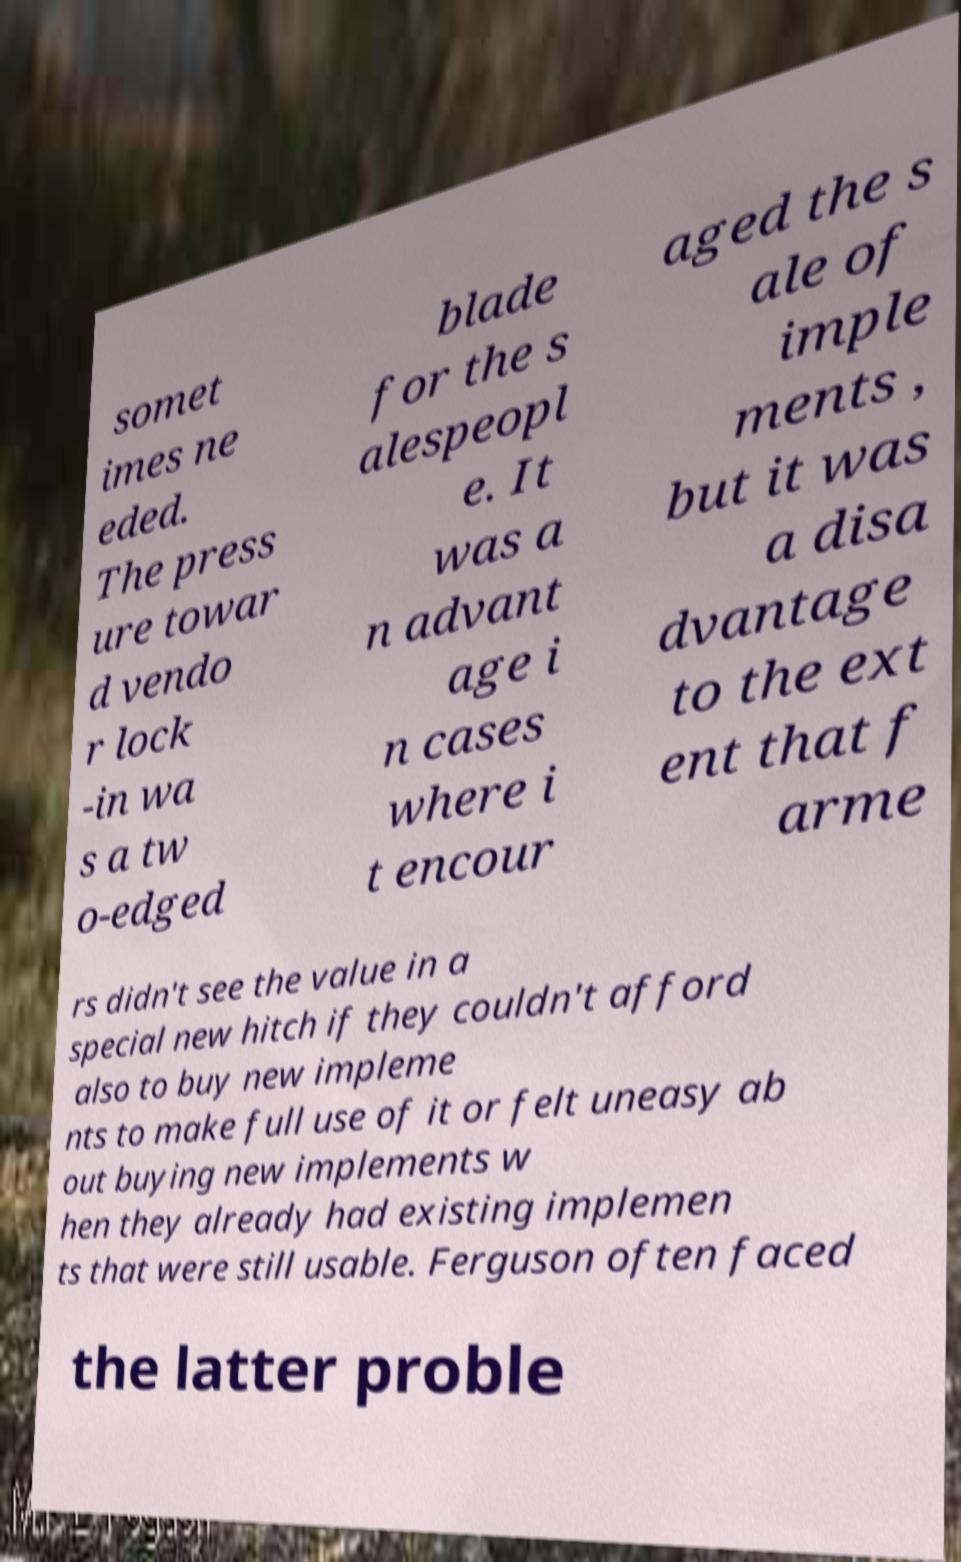Could you assist in decoding the text presented in this image and type it out clearly? somet imes ne eded. The press ure towar d vendo r lock -in wa s a tw o-edged blade for the s alespeopl e. It was a n advant age i n cases where i t encour aged the s ale of imple ments , but it was a disa dvantage to the ext ent that f arme rs didn't see the value in a special new hitch if they couldn't afford also to buy new impleme nts to make full use of it or felt uneasy ab out buying new implements w hen they already had existing implemen ts that were still usable. Ferguson often faced the latter proble 